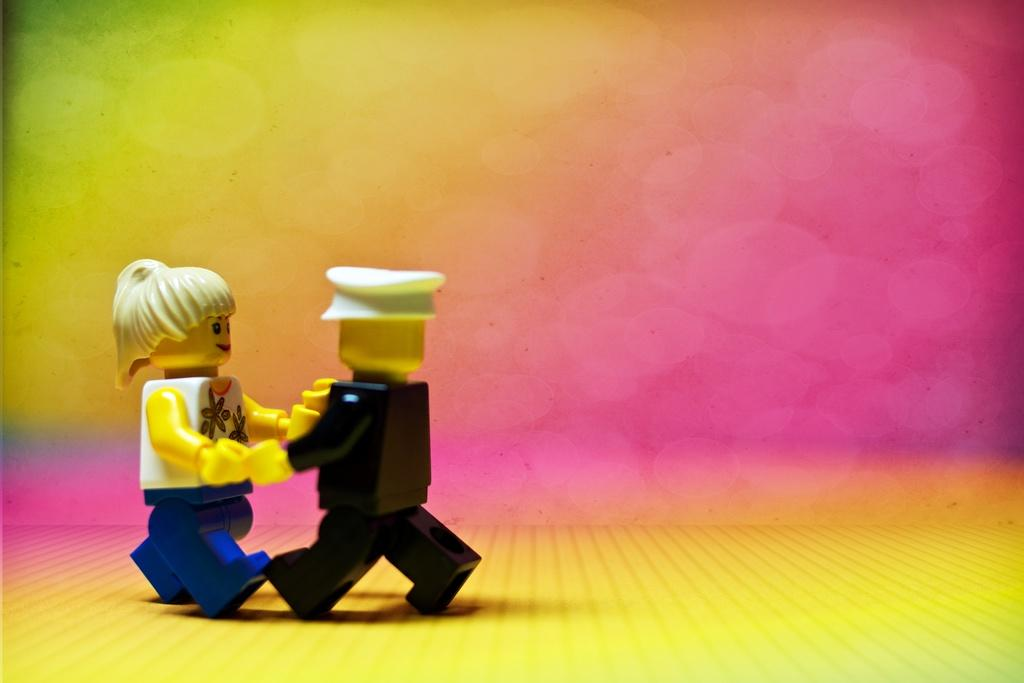What is shown in the image? There are depictions of persons in the image. What is the surface beneath the persons? There is a floor at the bottom of the image. How would you describe the background of the image? The background of the image is edited. What direction is the ray of light coming from in the image? There is no ray of light present in the image. How does the image show care for the environment? The image does not show any specific care for the environment; it only depicts persons and an edited background. 